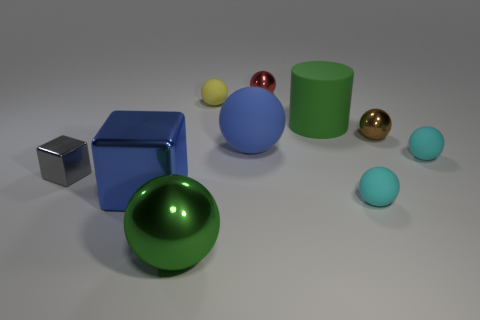Subtract 3 spheres. How many spheres are left? 4 Subtract all yellow balls. How many balls are left? 6 Subtract all tiny cyan rubber spheres. How many spheres are left? 5 Subtract all blue balls. Subtract all blue cylinders. How many balls are left? 6 Subtract all balls. How many objects are left? 3 Add 3 large purple rubber objects. How many large purple rubber objects exist? 3 Subtract 0 cyan cubes. How many objects are left? 10 Subtract all tiny cyan cylinders. Subtract all big cylinders. How many objects are left? 9 Add 7 tiny red metal objects. How many tiny red metal objects are left? 8 